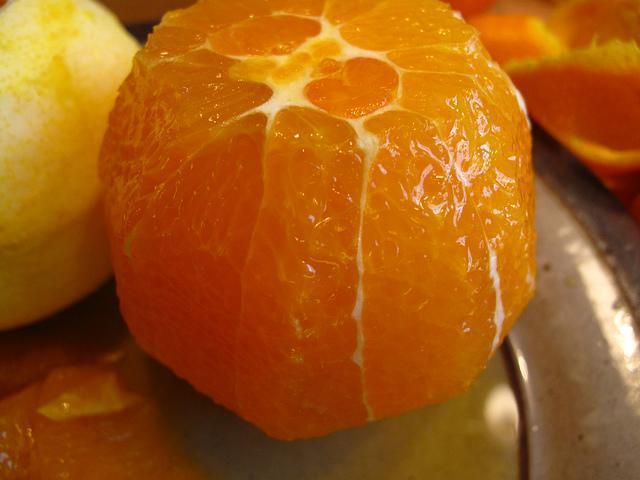How many oranges can you see?
Give a very brief answer. 2. 